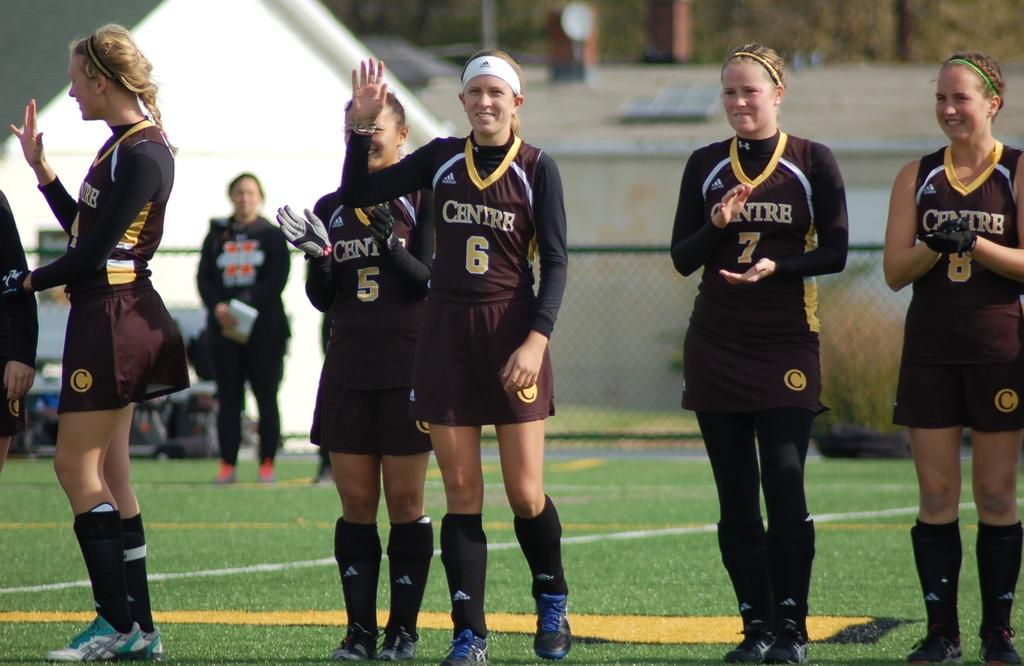<image>
Offer a succinct explanation of the picture presented. Girls that play for Centre stand in a line and cheer. 